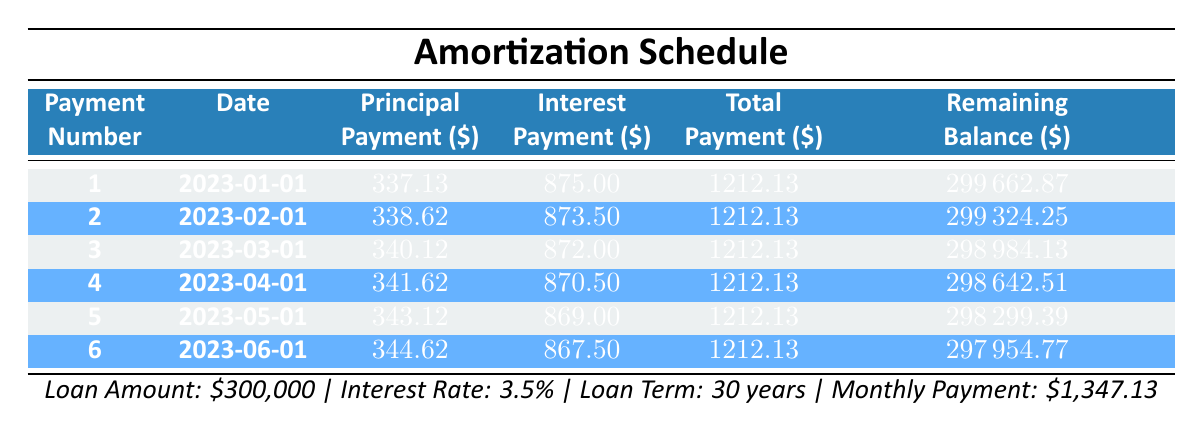What is the total payment for the first month? The total payment for the first month is listed in the "Total Payment" column for payment number 1, which is 1212.13.
Answer: 1212.13 How much does the principal payment increase from the first to the second month? The principal payment for the first month is 337.13 and for the second month it is 338.62. The difference is 338.62 - 337.13 = 1.49.
Answer: 1.49 Is the interest payment decreasing over the first six months? By examining the "Interest Payment" column, the values are 875.00, 873.50, 872.00, 870.50, 869.00, and 867.50, indicating a consistent decrease.
Answer: Yes What is the remaining balance after the sixth payment? Looking at the "Remaining Balance" column, the value after the sixth payment is 297954.77.
Answer: 297954.77 What is the average principal payment over the first six months? The principal payments for the first six months are 337.13, 338.62, 340.12, 341.62, 343.12, and 344.62. Summing these values gives 3385.13, and the average is 3385.13 / 6 = 564.19.
Answer: 564.19 How much total interest is paid after the first three months? The interest payments for the first three months are 875.00, 873.50, and 872.00. Summing these gives 875.00 + 873.50 + 872.00 = 2620.50 as the total interest.
Answer: 2620.50 What was the percentage of the payment allocated to interest in the second month? The total payment for the second month is 1212.13, and the interest payment is 873.50. To find the percentage, we use (873.50 / 1212.13) * 100 = 72.0%.
Answer: 72.0% How many payments remain after the fourth payment? A 30-year mortgage has 360 total payments. After 4 payments, there are 356 payments remaining.
Answer: 356 